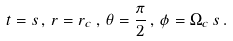Convert formula to latex. <formula><loc_0><loc_0><loc_500><loc_500>t = s \, , \, r = r _ { c } \, , \, \theta = \frac { \pi } { 2 } \, , \, \phi = \Omega _ { c } \, s \, .</formula> 